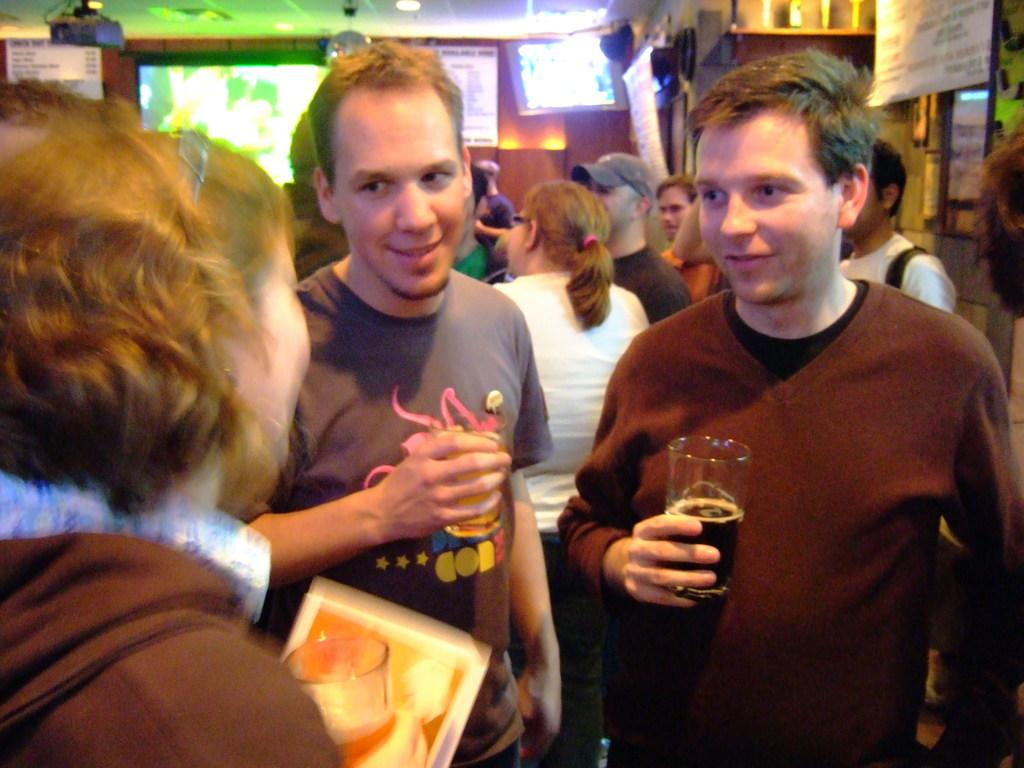What is happening in the image? There are people standing in the image. What are the two men holding? The two men are holding glasses. What can be seen in the background of the image? There are lights and a screen in the background of the image. What type of leather is the woman wearing in the image? There is no woman present in the image, and therefore no leather can be observed. 